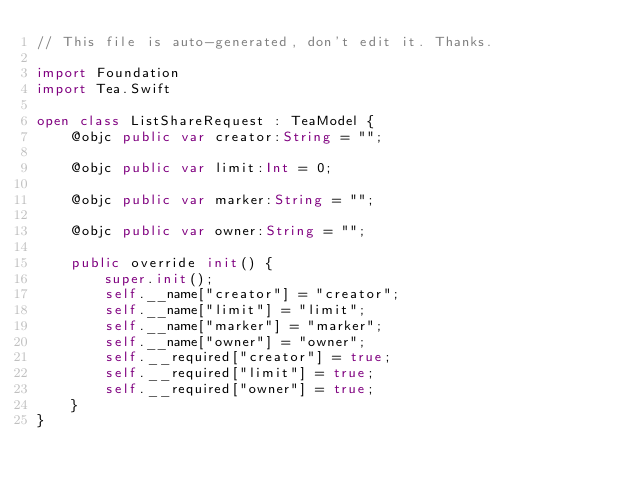Convert code to text. <code><loc_0><loc_0><loc_500><loc_500><_Swift_>// This file is auto-generated, don't edit it. Thanks.

import Foundation
import Tea.Swift

open class ListShareRequest : TeaModel {
    @objc public var creator:String = "";

    @objc public var limit:Int = 0;

    @objc public var marker:String = "";

    @objc public var owner:String = "";

    public override init() {
        super.init();
        self.__name["creator"] = "creator";
        self.__name["limit"] = "limit";
        self.__name["marker"] = "marker";
        self.__name["owner"] = "owner";
        self.__required["creator"] = true;
        self.__required["limit"] = true;
        self.__required["owner"] = true;
    }
}
</code> 